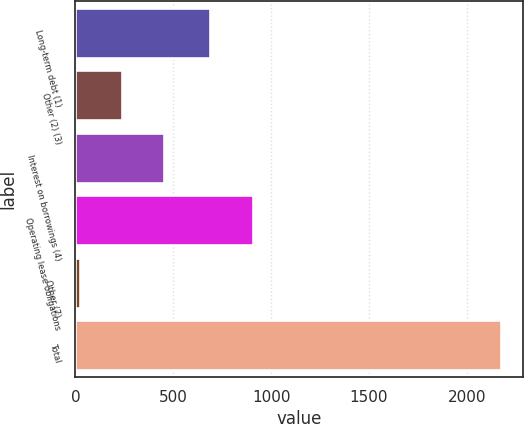Convert chart. <chart><loc_0><loc_0><loc_500><loc_500><bar_chart><fcel>Long-term debt (1)<fcel>Other (2) (3)<fcel>Interest on borrowings (4)<fcel>Operating lease obligations<fcel>Other (7)<fcel>Total<nl><fcel>690<fcel>240<fcel>455<fcel>905<fcel>25<fcel>2175<nl></chart> 